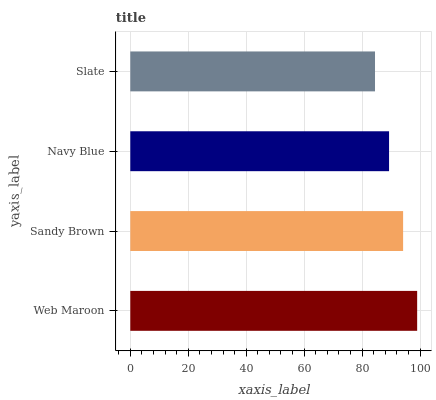Is Slate the minimum?
Answer yes or no. Yes. Is Web Maroon the maximum?
Answer yes or no. Yes. Is Sandy Brown the minimum?
Answer yes or no. No. Is Sandy Brown the maximum?
Answer yes or no. No. Is Web Maroon greater than Sandy Brown?
Answer yes or no. Yes. Is Sandy Brown less than Web Maroon?
Answer yes or no. Yes. Is Sandy Brown greater than Web Maroon?
Answer yes or no. No. Is Web Maroon less than Sandy Brown?
Answer yes or no. No. Is Sandy Brown the high median?
Answer yes or no. Yes. Is Navy Blue the low median?
Answer yes or no. Yes. Is Web Maroon the high median?
Answer yes or no. No. Is Sandy Brown the low median?
Answer yes or no. No. 